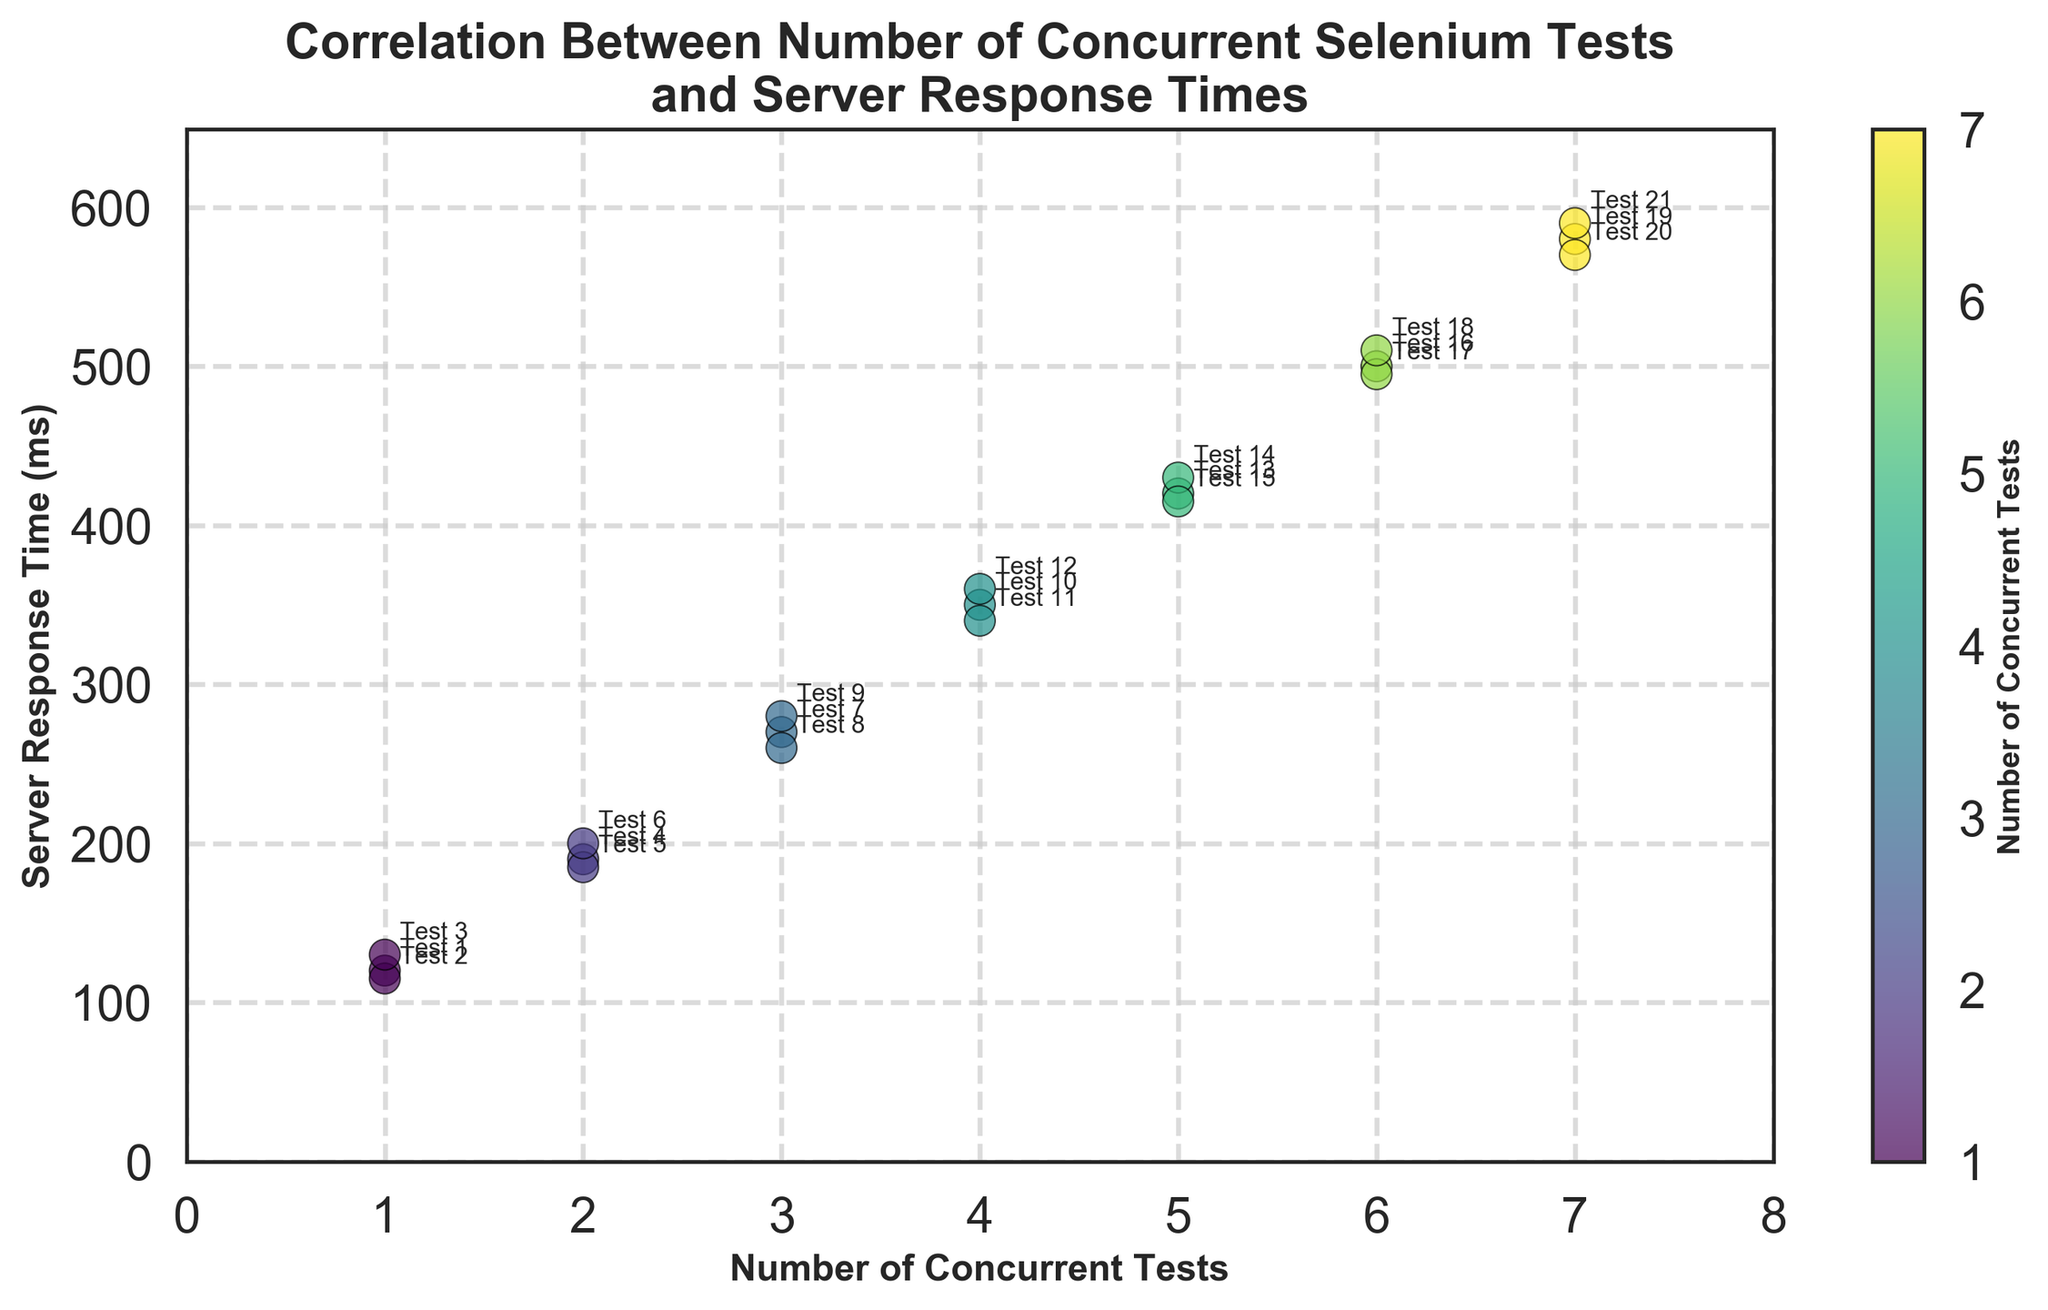what is the title of the plot? The title of the plot is displayed at the top center of the figure.
Answer: Correlation Between Number of Concurrent Selenium Tests and Server Response Times what are the labels on the X and Y axes? The X-axis label describes the horizontal axis while the Y-axis label describes the vertical axis. The X-axis label is 'Number of Concurrent Tests' and the Y-axis label is 'Server Response Time (ms)'.
Answer: 'Number of Concurrent Tests' and 'Server Response Time (ms)' how many data points are plotted in the figure? Each data point represents an entry in the dataset. By counting the points or looking at the annotated test IDs, we can determine the number. There are 21 data points plotted on the figure.
Answer: 21 how does the server response time change as the number of concurrent tests increases? By observing the scatter plot, we can see the trend between X and Y. As the number of concurrent tests increases, the server response time also increases, showing a positive correlation.
Answer: increases which test ID has the highest server response time and what is that time? Look for the highest Y value and refer to the annotated test ID. The highest server response time is for Test 21, which is around 590 ms.
Answer: Test 21, 590 ms what is the range of server response times for 4 concurrent tests? Look at the data points where the number of concurrent tests is 4 and observe their Y values. The range is from the smallest to the largest Y values. The range for 4 concurrent tests goes from 340 ms to 360 ms.
Answer: 340 ms to 360 ms how many test points have a server response time above 400 ms? Count the number of data points above the Y value of 400 ms. There are 9 data points with server response times above 400 ms.
Answer: 9 which test has the lowest server response time and what is that time? Identify the data point with the lowest Y value and check the annotated test ID. The lowest server response time is for Test 2, which is around 115 ms.
Answer: Test 2, 115 ms do higher numbers of concurrent tests generally lead to higher server response times? Look at the overall trend in the scatter plot. We see a general trend where higher numbers of concurrent tests correspond to higher server response times, indicating a positive correlation.
Answer: yes 